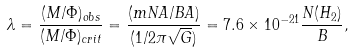<formula> <loc_0><loc_0><loc_500><loc_500>\lambda = \frac { ( M / \Phi ) _ { o b s } } { ( M / \Phi ) _ { c r i t } } = \frac { ( m N A / B A ) } { ( 1 / 2 \pi \sqrt { G } ) } = 7 . 6 \times 1 0 ^ { - 2 1 } \frac { N ( H _ { 2 } ) } { B } ,</formula> 